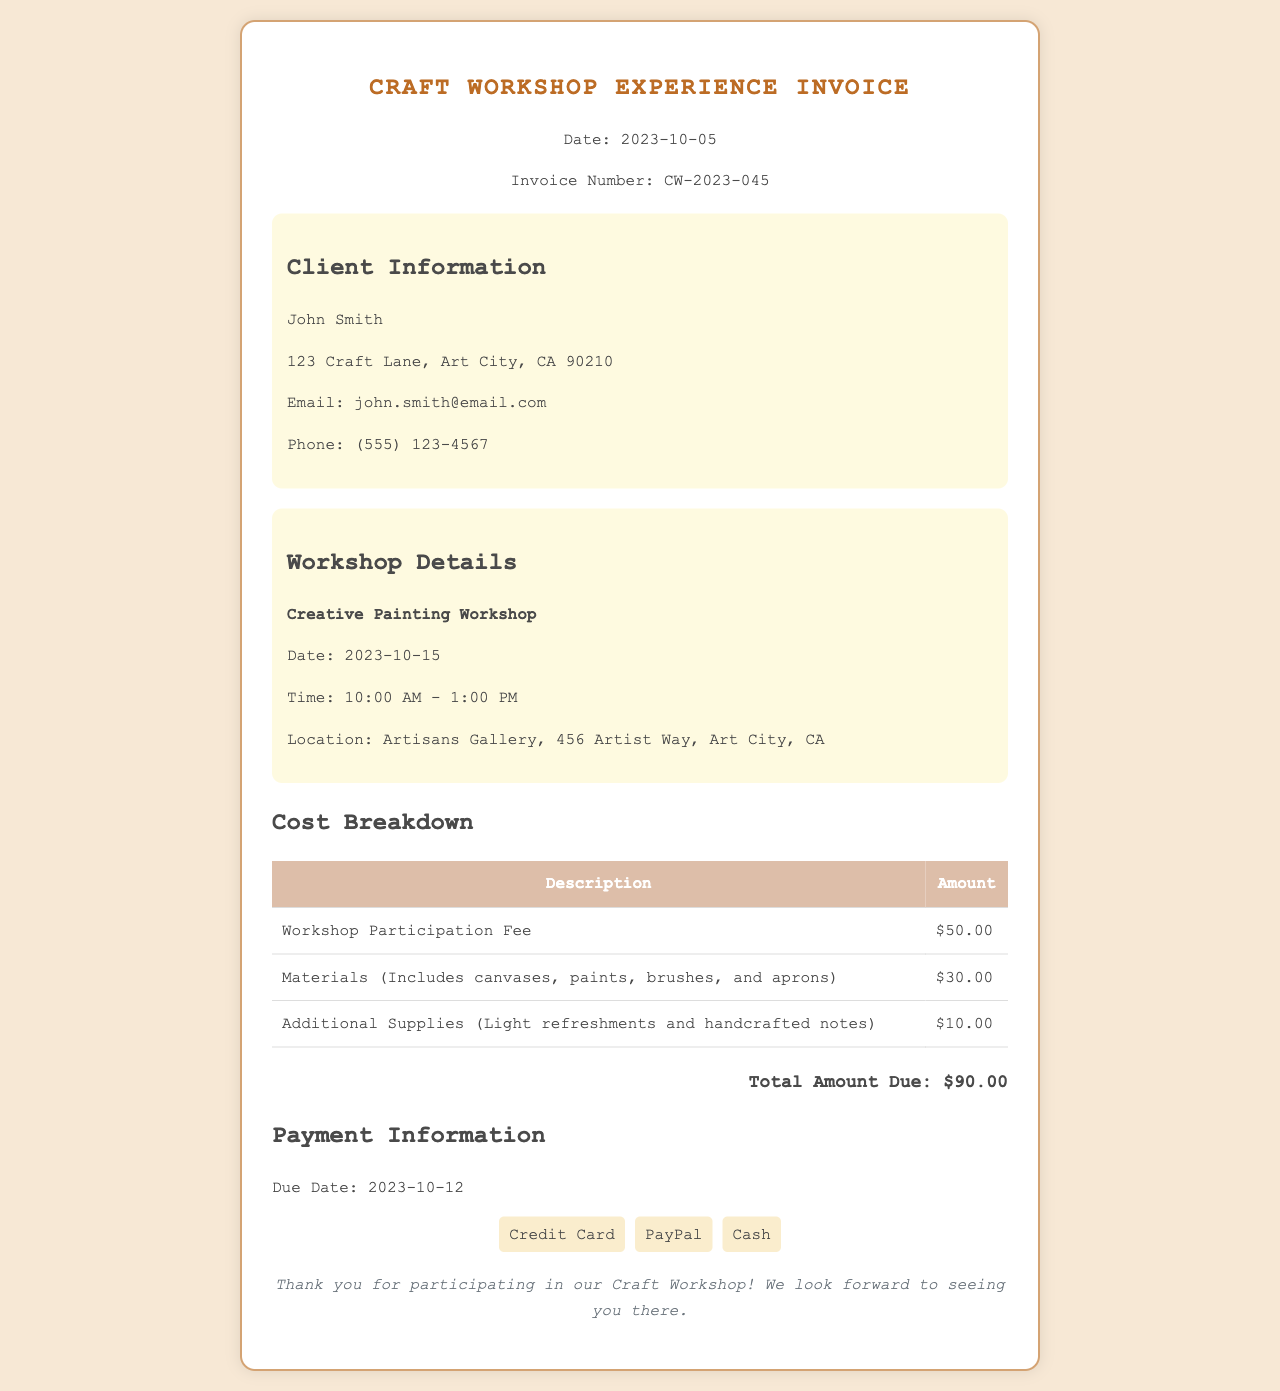What is the workshop title? The workshop title is mentioned under the workshop details, specifically stating "Creative Painting Workshop."
Answer: Creative Painting Workshop What is the total amount due? The total amount due is listed at the end of the cost breakdown section, which sums up all charges.
Answer: $90.00 When is the workshop date? The workshop date is explicitly provided in the workshop details section as "2023-10-15."
Answer: 2023-10-15 How much is the workshop participation fee? The workshop participation fee is described in the cost breakdown section with a specific amount.
Answer: $50.00 What is the due date for payment? The due date for payment is noted in the payment information section.
Answer: 2023-10-12 What location is the workshop being held at? The location of the workshop is found in the workshop details section, specifying the venue.
Answer: Artisans Gallery, 456 Artist Way, Art City, CA How much do the materials cost? The cost of materials is stated in the cost breakdown table, specifically for materials provided during the workshop.
Answer: $30.00 What additional supplies are included? The additional supplies are listed in the cost breakdown and specify what they encompass.
Answer: Light refreshments and handcrafted notes What payment methods are accepted? The accepted payment methods are indicated in the payment information section, showcasing the various options.
Answer: Credit Card, PayPal, Cash 